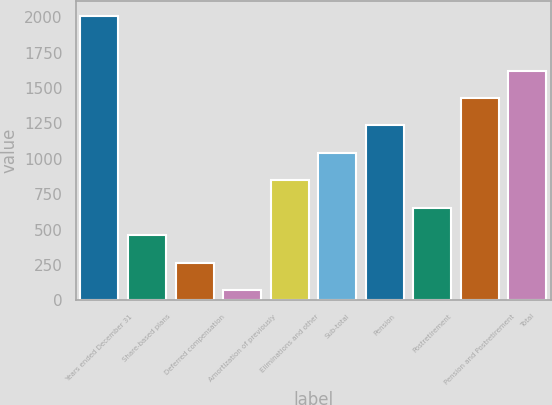Convert chart. <chart><loc_0><loc_0><loc_500><loc_500><bar_chart><fcel>Years ended December 31<fcel>Share-based plans<fcel>Deferred compensation<fcel>Amortization of previously<fcel>Eliminations and other<fcel>Sub-total<fcel>Pension<fcel>Postretirement<fcel>Pension and Postretirement<fcel>Total<nl><fcel>2012<fcel>458.4<fcel>264.2<fcel>70<fcel>846.8<fcel>1041<fcel>1235.2<fcel>652.6<fcel>1429.4<fcel>1623.6<nl></chart> 